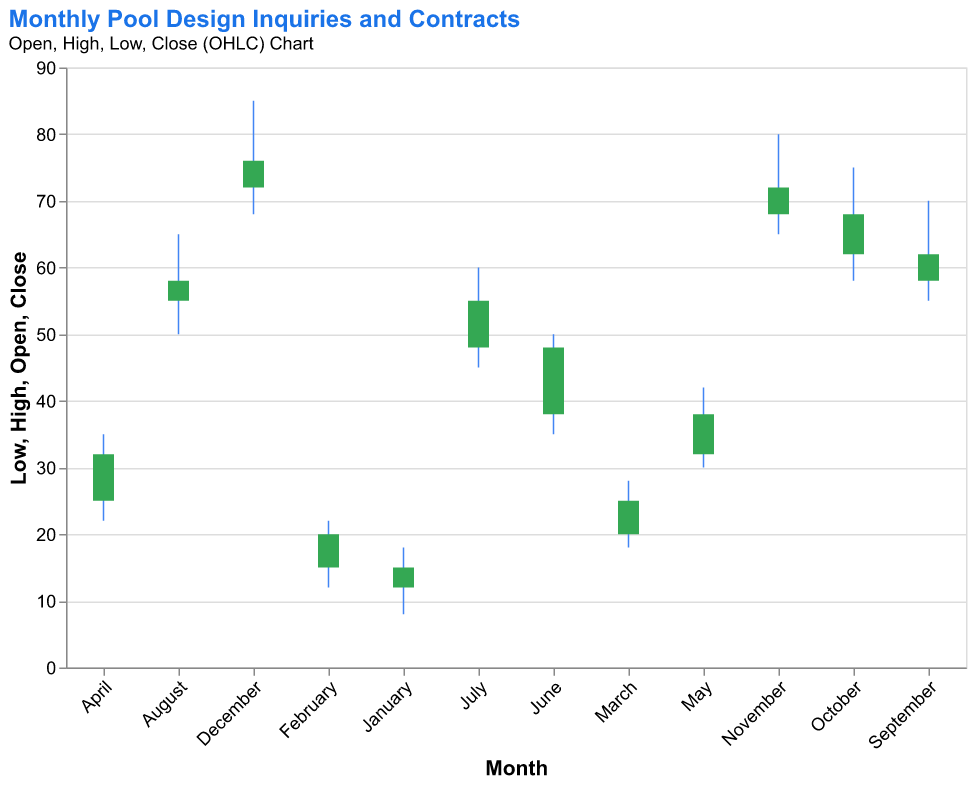What is the highest value recorded in the chart? The highest value recorded in the chart is represented by the 'High' value. According to the dataset, the highest 'High' value is 85 in December.
Answer: 85 How many months show an increase in the 'Close' value compared to the 'Open' value? To determine this, we need to count the months where the 'Close' value is greater than the 'Open' value. All months show an increase: Jan (15>12), Feb (20>15), Mar (25>20), Apr (32>25), May (38>32), Jun (48>38), Jul (55>48), Aug (58>55), Sept (62>58), Oct (68>62), Nov (72>68), Dec (76>72).
Answer: 12 Which month has the smallest range between 'High' and 'Low' values? The range between 'High' and 'Low' values is calculated by subtracting 'Low' from 'High' for each month. The smallest range is in February (22-12=10).
Answer: February What is the average 'Close' value for the first quarter (January to March)? To calculate the average 'Close' value for Q1: (15 + 20 + 25) / 3 = 60 / 3 = 20.
Answer: 20 Which months have a 'Low' value above 50? By examining the 'Low' values, the months with 'Low' values above 50 are: August (50), September (55), October (58), November (65), and December (68).
Answer: August, September, October, November, December What is the difference between the 'High' values of the month with the highest 'Close' and the month with the lowest 'Close'? December has the highest 'Close' (76), with a 'High' of 85. January has the lowest 'Close' (15), with a 'High' of 18. The difference is 85 - 18 = 67.
Answer: 67 In which month does the 'Open' value first exceed 50? The 'Open' value exceeds 50 for the first time in August (Open=55).
Answer: August How much did the 'Open' value increase from January to December? To calculate the increase, subtract the January 'Open' value from the December 'Open' value: 72 - 12 = 60.
Answer: 60 What is the highest 'Close' value in the second half of the year? The second half of the year is from July to December. The highest 'Close' value in this period is December with 76.
Answer: 76 